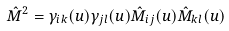<formula> <loc_0><loc_0><loc_500><loc_500>\hat { M } ^ { 2 } = \gamma _ { i k } ( u ) \gamma _ { j l } ( u ) \hat { M } _ { i j } ( u ) \hat { M } _ { k l } ( u )</formula> 